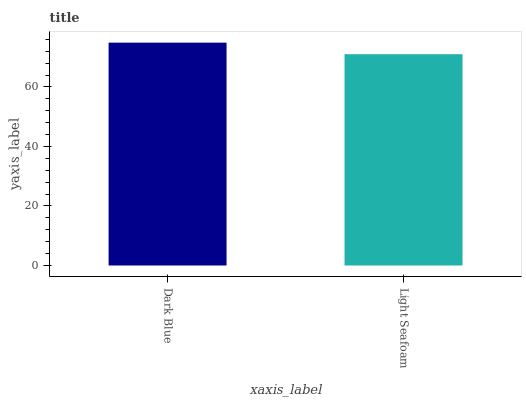Is Light Seafoam the minimum?
Answer yes or no. Yes. Is Dark Blue the maximum?
Answer yes or no. Yes. Is Light Seafoam the maximum?
Answer yes or no. No. Is Dark Blue greater than Light Seafoam?
Answer yes or no. Yes. Is Light Seafoam less than Dark Blue?
Answer yes or no. Yes. Is Light Seafoam greater than Dark Blue?
Answer yes or no. No. Is Dark Blue less than Light Seafoam?
Answer yes or no. No. Is Dark Blue the high median?
Answer yes or no. Yes. Is Light Seafoam the low median?
Answer yes or no. Yes. Is Light Seafoam the high median?
Answer yes or no. No. Is Dark Blue the low median?
Answer yes or no. No. 